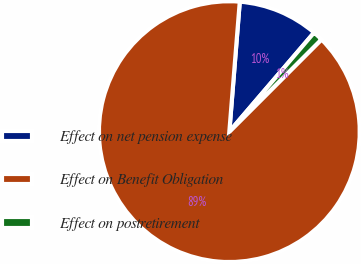Convert chart to OTSL. <chart><loc_0><loc_0><loc_500><loc_500><pie_chart><fcel>Effect on net pension expense<fcel>Effect on Benefit Obligation<fcel>Effect on postretirement<nl><fcel>9.99%<fcel>88.78%<fcel>1.23%<nl></chart> 